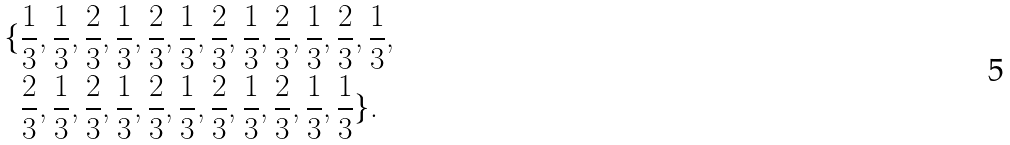<formula> <loc_0><loc_0><loc_500><loc_500>\{ & \frac { 1 } { 3 } , \frac { 1 } { 3 } , \frac { 2 } { 3 } , \frac { 1 } { 3 } , \frac { 2 } { 3 } , \frac { 1 } { 3 } , \frac { 2 } { 3 } , \frac { 1 } { 3 } , \frac { 2 } { 3 } , \frac { 1 } { 3 } , \frac { 2 } { 3 } , \frac { 1 } { 3 } , \\ & \frac { 2 } { 3 } , \frac { 1 } { 3 } , \frac { 2 } { 3 } , \frac { 1 } { 3 } , \frac { 2 } { 3 } , \frac { 1 } { 3 } , \frac { 2 } { 3 } , \frac { 1 } { 3 } , \frac { 2 } { 3 } , \frac { 1 } { 3 } , \frac { 1 } { 3 } \} .</formula> 